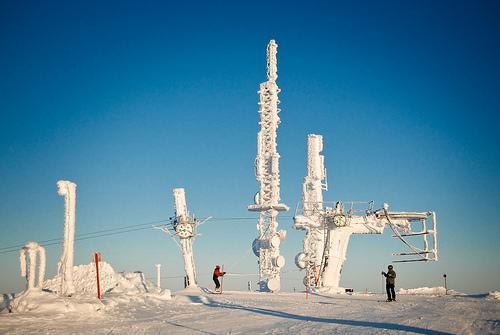How many people are there?
Give a very brief answer. 2. 